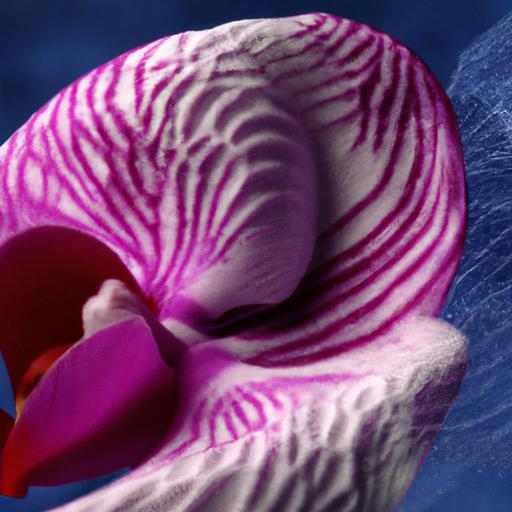Can you describe the texture of the flower? Certainly! The orchid petals in the image have a smooth, velvety texture, with some ridges and veins that provide depth and character to its surface. The visual contrast highlights the intricate details and gives the flower a three-dimensional quality. 